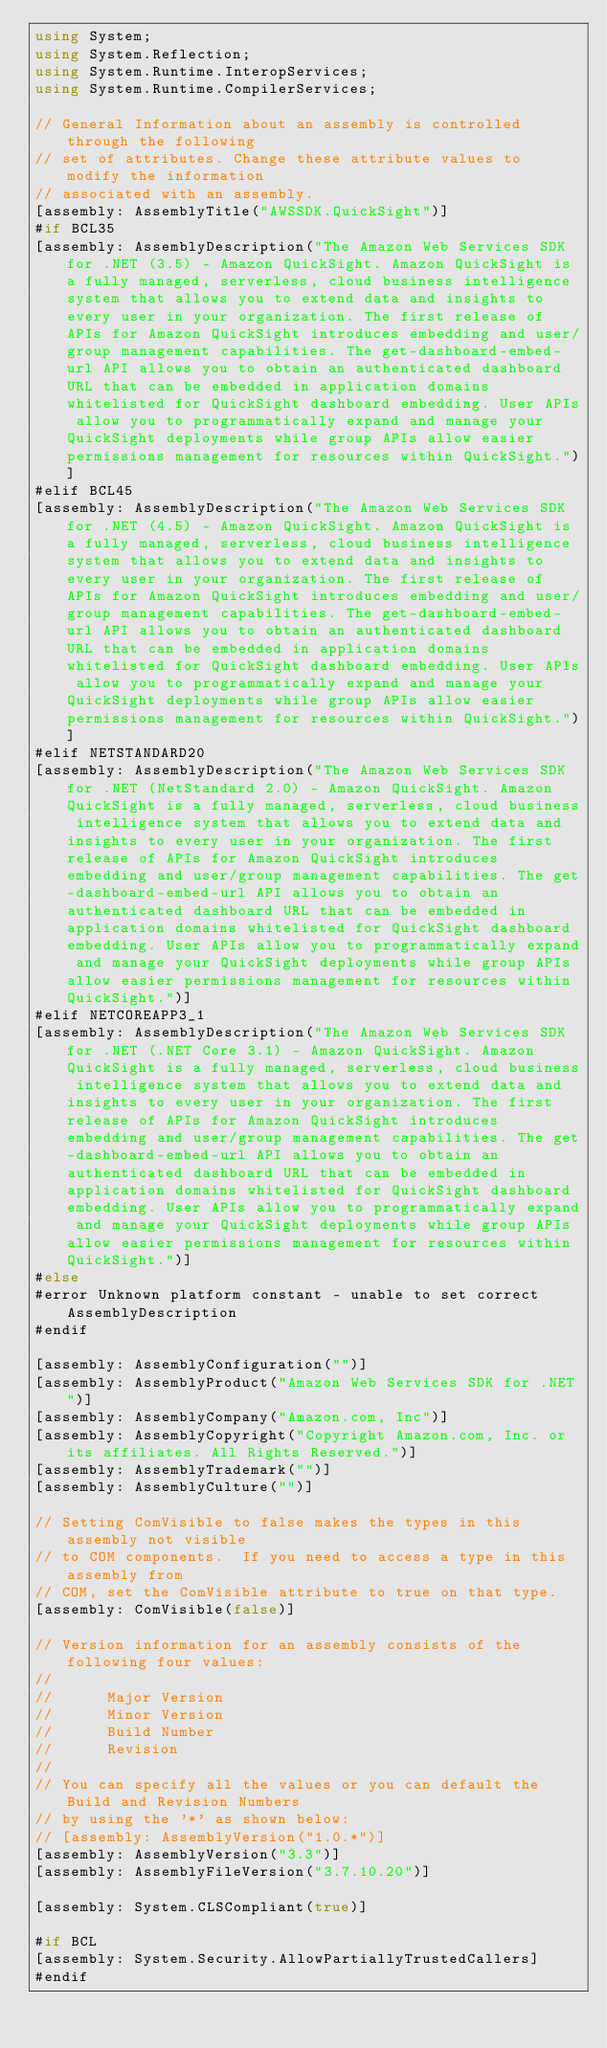Convert code to text. <code><loc_0><loc_0><loc_500><loc_500><_C#_>using System;
using System.Reflection;
using System.Runtime.InteropServices;
using System.Runtime.CompilerServices;

// General Information about an assembly is controlled through the following 
// set of attributes. Change these attribute values to modify the information
// associated with an assembly.
[assembly: AssemblyTitle("AWSSDK.QuickSight")]
#if BCL35
[assembly: AssemblyDescription("The Amazon Web Services SDK for .NET (3.5) - Amazon QuickSight. Amazon QuickSight is a fully managed, serverless, cloud business intelligence system that allows you to extend data and insights to every user in your organization. The first release of APIs for Amazon QuickSight introduces embedding and user/group management capabilities. The get-dashboard-embed-url API allows you to obtain an authenticated dashboard URL that can be embedded in application domains whitelisted for QuickSight dashboard embedding. User APIs allow you to programmatically expand and manage your QuickSight deployments while group APIs allow easier permissions management for resources within QuickSight.")]
#elif BCL45
[assembly: AssemblyDescription("The Amazon Web Services SDK for .NET (4.5) - Amazon QuickSight. Amazon QuickSight is a fully managed, serverless, cloud business intelligence system that allows you to extend data and insights to every user in your organization. The first release of APIs for Amazon QuickSight introduces embedding and user/group management capabilities. The get-dashboard-embed-url API allows you to obtain an authenticated dashboard URL that can be embedded in application domains whitelisted for QuickSight dashboard embedding. User APIs allow you to programmatically expand and manage your QuickSight deployments while group APIs allow easier permissions management for resources within QuickSight.")]
#elif NETSTANDARD20
[assembly: AssemblyDescription("The Amazon Web Services SDK for .NET (NetStandard 2.0) - Amazon QuickSight. Amazon QuickSight is a fully managed, serverless, cloud business intelligence system that allows you to extend data and insights to every user in your organization. The first release of APIs for Amazon QuickSight introduces embedding and user/group management capabilities. The get-dashboard-embed-url API allows you to obtain an authenticated dashboard URL that can be embedded in application domains whitelisted for QuickSight dashboard embedding. User APIs allow you to programmatically expand and manage your QuickSight deployments while group APIs allow easier permissions management for resources within QuickSight.")]
#elif NETCOREAPP3_1
[assembly: AssemblyDescription("The Amazon Web Services SDK for .NET (.NET Core 3.1) - Amazon QuickSight. Amazon QuickSight is a fully managed, serverless, cloud business intelligence system that allows you to extend data and insights to every user in your organization. The first release of APIs for Amazon QuickSight introduces embedding and user/group management capabilities. The get-dashboard-embed-url API allows you to obtain an authenticated dashboard URL that can be embedded in application domains whitelisted for QuickSight dashboard embedding. User APIs allow you to programmatically expand and manage your QuickSight deployments while group APIs allow easier permissions management for resources within QuickSight.")]
#else
#error Unknown platform constant - unable to set correct AssemblyDescription
#endif

[assembly: AssemblyConfiguration("")]
[assembly: AssemblyProduct("Amazon Web Services SDK for .NET")]
[assembly: AssemblyCompany("Amazon.com, Inc")]
[assembly: AssemblyCopyright("Copyright Amazon.com, Inc. or its affiliates. All Rights Reserved.")]
[assembly: AssemblyTrademark("")]
[assembly: AssemblyCulture("")]

// Setting ComVisible to false makes the types in this assembly not visible 
// to COM components.  If you need to access a type in this assembly from 
// COM, set the ComVisible attribute to true on that type.
[assembly: ComVisible(false)]

// Version information for an assembly consists of the following four values:
//
//      Major Version
//      Minor Version 
//      Build Number
//      Revision
//
// You can specify all the values or you can default the Build and Revision Numbers 
// by using the '*' as shown below:
// [assembly: AssemblyVersion("1.0.*")]
[assembly: AssemblyVersion("3.3")]
[assembly: AssemblyFileVersion("3.7.10.20")]

[assembly: System.CLSCompliant(true)]

#if BCL
[assembly: System.Security.AllowPartiallyTrustedCallers]
#endif</code> 